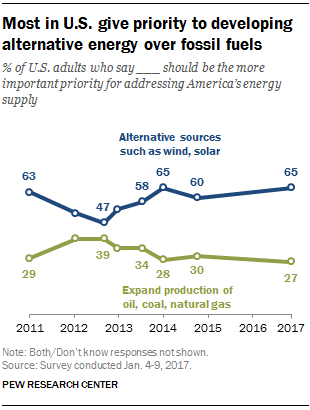Highlight a few significant elements in this photo. In 2013, a significant percentage of respondents believed that alternative sources such as wind and solar should be given higher priority in addressing America's energy supply. In 2017, the value of expanding production of oil, coal, and natural gas was considered a more important priority for addressing America's energy supply than other options. 